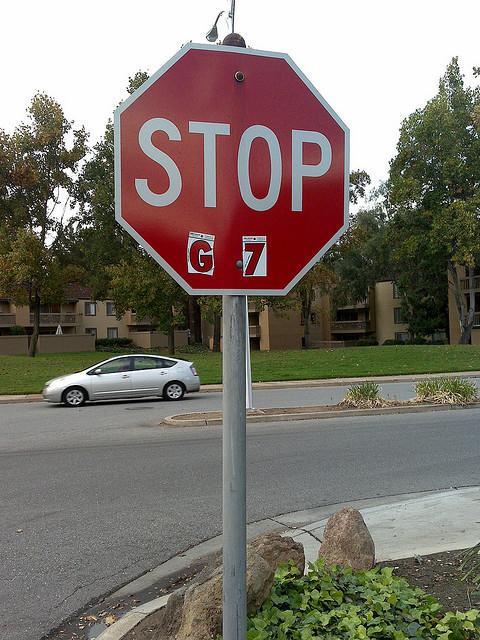How many cars are in the picture?
Short answer required. 1. How many signs are there?
Quick response, please. 1. What kind of street sign is this?
Be succinct. Stop. How many cars are shown?
Answer briefly. 1. How many cars can be seen?
Give a very brief answer. 1. What color is the car in the background?
Answer briefly. Silver. How many signs are near the road?
Quick response, please. 1. 